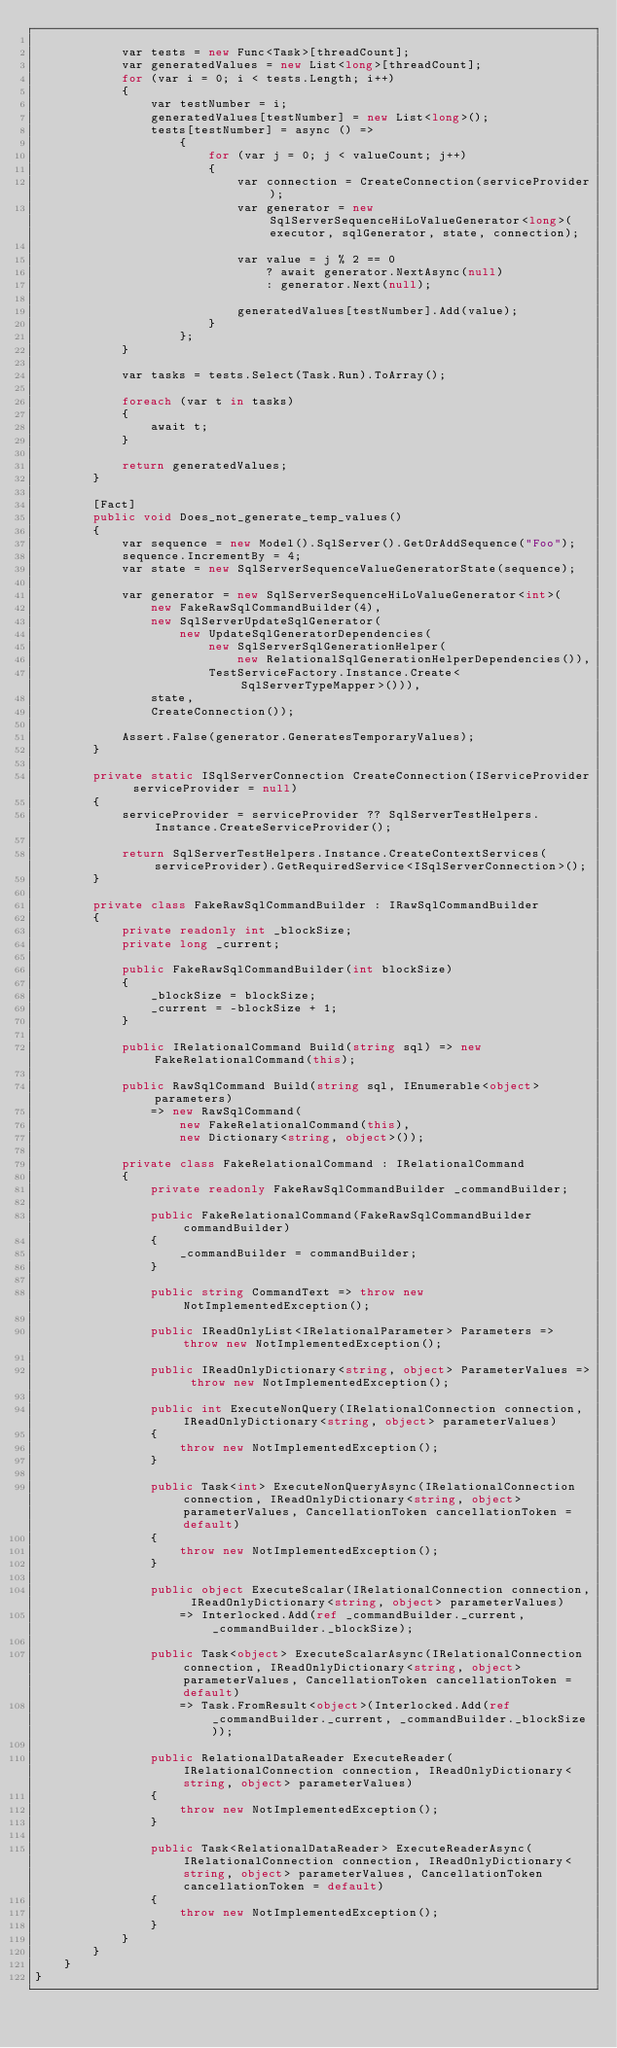Convert code to text. <code><loc_0><loc_0><loc_500><loc_500><_C#_>
            var tests = new Func<Task>[threadCount];
            var generatedValues = new List<long>[threadCount];
            for (var i = 0; i < tests.Length; i++)
            {
                var testNumber = i;
                generatedValues[testNumber] = new List<long>();
                tests[testNumber] = async () =>
                    {
                        for (var j = 0; j < valueCount; j++)
                        {
                            var connection = CreateConnection(serviceProvider);
                            var generator = new SqlServerSequenceHiLoValueGenerator<long>(executor, sqlGenerator, state, connection);

                            var value = j % 2 == 0
                                ? await generator.NextAsync(null)
                                : generator.Next(null);

                            generatedValues[testNumber].Add(value);
                        }
                    };
            }

            var tasks = tests.Select(Task.Run).ToArray();

            foreach (var t in tasks)
            {
                await t;
            }

            return generatedValues;
        }

        [Fact]
        public void Does_not_generate_temp_values()
        {
            var sequence = new Model().SqlServer().GetOrAddSequence("Foo");
            sequence.IncrementBy = 4;
            var state = new SqlServerSequenceValueGeneratorState(sequence);

            var generator = new SqlServerSequenceHiLoValueGenerator<int>(
                new FakeRawSqlCommandBuilder(4),
                new SqlServerUpdateSqlGenerator(
                    new UpdateSqlGeneratorDependencies(
                        new SqlServerSqlGenerationHelper(
                            new RelationalSqlGenerationHelperDependencies()),
                        TestServiceFactory.Instance.Create<SqlServerTypeMapper>())),
                state,
                CreateConnection());

            Assert.False(generator.GeneratesTemporaryValues);
        }

        private static ISqlServerConnection CreateConnection(IServiceProvider serviceProvider = null)
        {
            serviceProvider = serviceProvider ?? SqlServerTestHelpers.Instance.CreateServiceProvider();

            return SqlServerTestHelpers.Instance.CreateContextServices(serviceProvider).GetRequiredService<ISqlServerConnection>();
        }

        private class FakeRawSqlCommandBuilder : IRawSqlCommandBuilder
        {
            private readonly int _blockSize;
            private long _current;

            public FakeRawSqlCommandBuilder(int blockSize)
            {
                _blockSize = blockSize;
                _current = -blockSize + 1;
            }

            public IRelationalCommand Build(string sql) => new FakeRelationalCommand(this);

            public RawSqlCommand Build(string sql, IEnumerable<object> parameters)
                => new RawSqlCommand(
                    new FakeRelationalCommand(this),
                    new Dictionary<string, object>());

            private class FakeRelationalCommand : IRelationalCommand
            {
                private readonly FakeRawSqlCommandBuilder _commandBuilder;

                public FakeRelationalCommand(FakeRawSqlCommandBuilder commandBuilder)
                {
                    _commandBuilder = commandBuilder;
                }

                public string CommandText => throw new NotImplementedException();

                public IReadOnlyList<IRelationalParameter> Parameters => throw new NotImplementedException();

                public IReadOnlyDictionary<string, object> ParameterValues => throw new NotImplementedException();

                public int ExecuteNonQuery(IRelationalConnection connection, IReadOnlyDictionary<string, object> parameterValues)
                {
                    throw new NotImplementedException();
                }

                public Task<int> ExecuteNonQueryAsync(IRelationalConnection connection, IReadOnlyDictionary<string, object> parameterValues, CancellationToken cancellationToken = default)
                {
                    throw new NotImplementedException();
                }

                public object ExecuteScalar(IRelationalConnection connection, IReadOnlyDictionary<string, object> parameterValues)
                    => Interlocked.Add(ref _commandBuilder._current, _commandBuilder._blockSize);

                public Task<object> ExecuteScalarAsync(IRelationalConnection connection, IReadOnlyDictionary<string, object> parameterValues, CancellationToken cancellationToken = default)
                    => Task.FromResult<object>(Interlocked.Add(ref _commandBuilder._current, _commandBuilder._blockSize));

                public RelationalDataReader ExecuteReader(IRelationalConnection connection, IReadOnlyDictionary<string, object> parameterValues)
                {
                    throw new NotImplementedException();
                }

                public Task<RelationalDataReader> ExecuteReaderAsync(IRelationalConnection connection, IReadOnlyDictionary<string, object> parameterValues, CancellationToken cancellationToken = default)
                {
                    throw new NotImplementedException();
                }
            }
        }
    }
}
</code> 